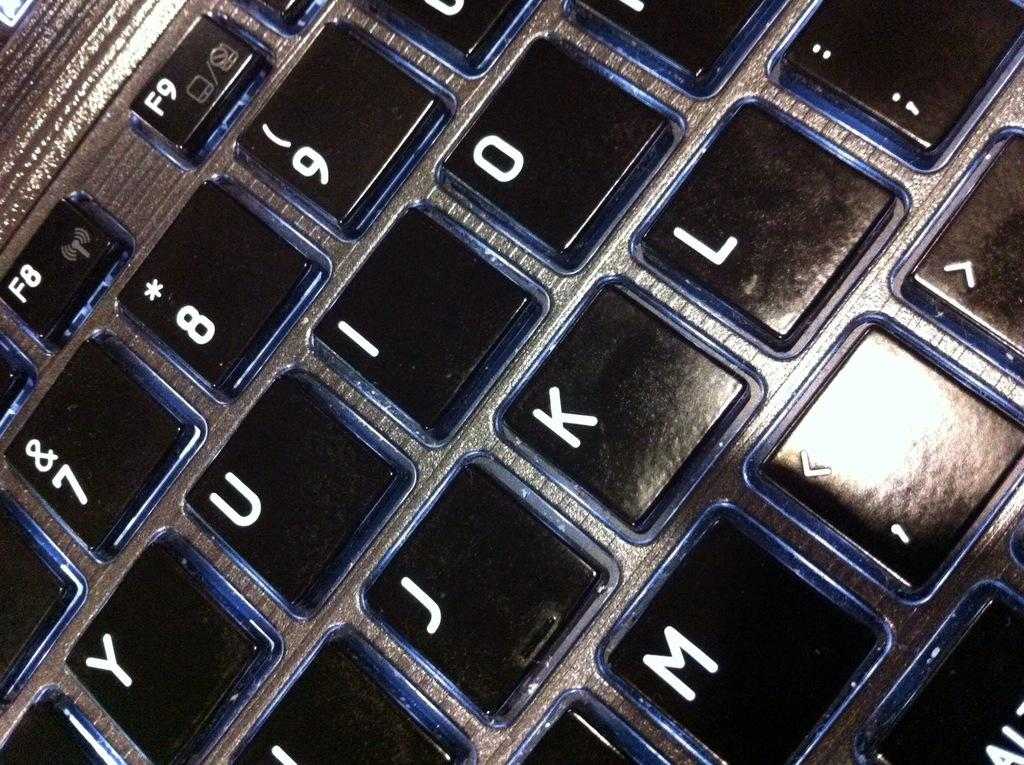<image>
Give a short and clear explanation of the subsequent image. a close up of a keyboard with the letters J and K visible. 